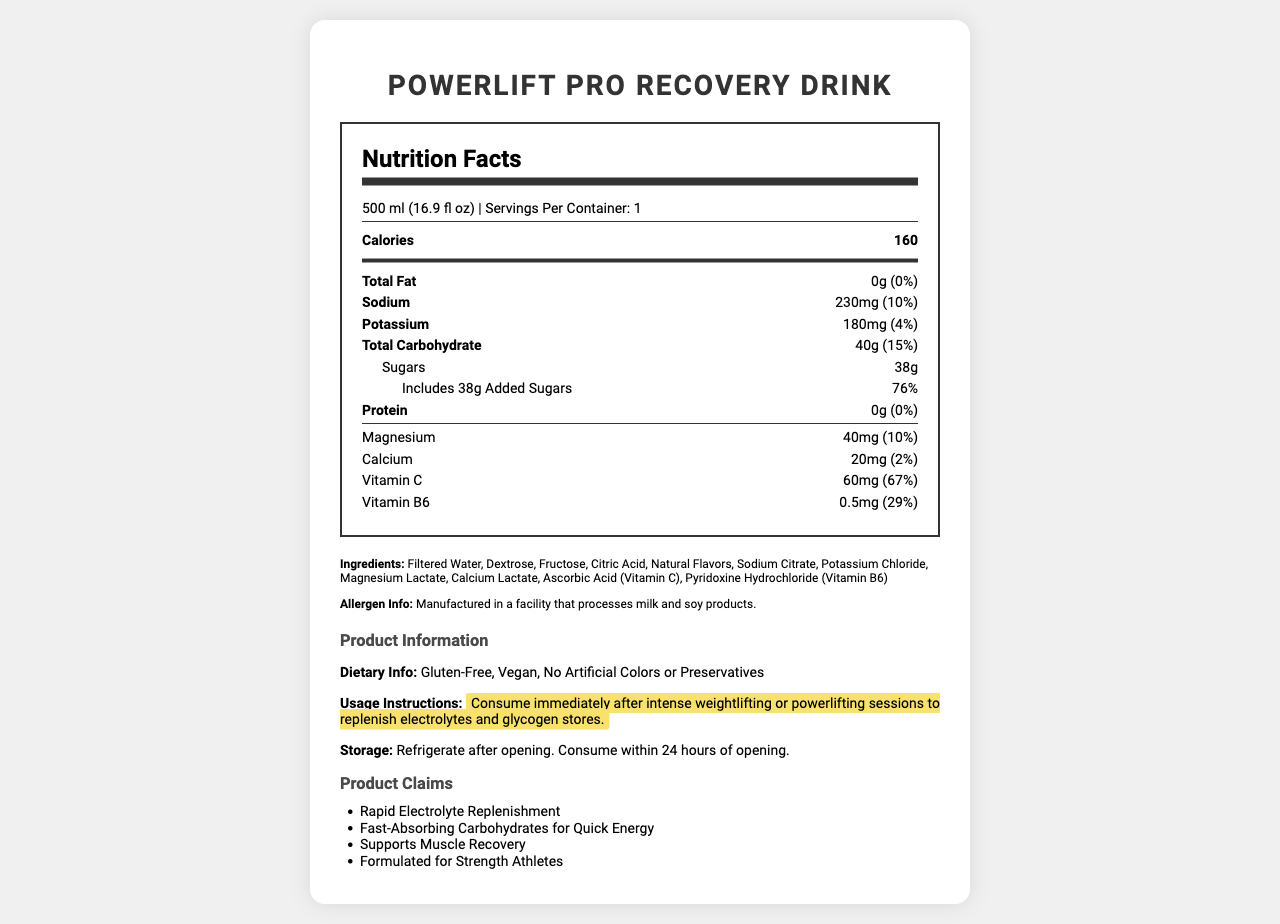what is the serving size of PowerLift Pro Recovery Drink? The serving size is mentioned at the beginning of the nutrition label under the "Nutrition Facts" heading.
Answer: 500 ml (16.9 fl oz) How many calories are there in one serving? The number of calories is listed in a bold font in the nutrition label.
Answer: 160 What is the total carbohydrate content per serving? The total carbohydrate content is displayed under the nutrition information, along with the daily value percentage.
Answer: 40g (15%) How much sodium does this drink contain per serving? The amount of sodium is given as 230mg, which constitutes 10% of the daily value.
Answer: 230mg (10%) What minerals are present in the PowerLift Pro Recovery Drink? These minerals are listed along with their respective amounts and daily values in the nutrition label.
Answer: Sodium, Potassium, Magnesium, Calcium Does this drink contain any added sugars? Under the sugars section, it mentions "Includes 38g Added Sugars" with a daily value percentage of 76%.
Answer: Yes Which vitamin has the highest daily value percentage in this drink? A. Vitamin A B. Vitamin C C. Vitamin D D. Vitamin B6 Vitamin C (60mg) has the highest daily value percentage of 67% compared to other vitamins listed.
Answer: B What kind of dietary claims are made about PowerLift Pro Recovery Drink? A. Gluten-Free, Vegan B. Contains Artificial Colors, Contains Preservatives C. Low Sodium, Low Sugar The drink is claimed to be Gluten-Free and Vegan according to the product information section.
Answer: A Are there any allergens associated with the PowerLift Pro Recovery Drink? The allergen information states that it is manufactured in a facility that processes milk and soy products.
Answer: Yes Is this product recommended to be consumed after weightlifting sessions? The usage instructions highlight that it should be consumed immediately after intense weightlifting or powerlifting sessions.
Answer: Yes Summarize the main idea of the PowerLift Pro Recovery Drink nutrition facts label. The document provides detailed nutritional information, ingredients, allergen info, dietary claims, usage instructions, and product claims designed to highlight the drink's benefits for recovery and electrolyte replenishment.
Answer: The PowerLift Pro Recovery Drink is a post-workout beverage designed to replenish electrolytes and glycogen stores. It contains key nutrients such as sodium, potassium, magnesium, and vitamins C and B6. The drink is gluten-free, vegan, and contains no artificial colors or preservatives, but it includes 38g of added sugars. It provides 160 calories per 500 ml serving and is recommended for consumption after intense weightlifting sessions. How many grams of protein are in each serving of this drink? The protein content is listed as "0g" with a daily value percentage of "0%".
Answer: 0g What is the main source of carbohydrates in the PowerLift Pro Recovery Drink? The ingredients list specifically mentions dextrose and fructose, which are types of sugars and fast-absorbing carbohydrates.
Answer: Dextrose, Fructose How should this drink be stored after opening? The storage instructions specify that the drink should be refrigerated after opening and consumed within 24 hours.
Answer: Refrigerate after opening. Consume within 24 hours of opening. How many servings are there per container of the PowerLift Pro Recovery Drink? The label states that there is one serving per container.
Answer: 1 What is the total fat content in each serving? The total fat content is indicated as "0g" with a daily value percentage of "0%".
Answer: 0g (0%) Can you determine if this drink is low in sugar? The drink contains 38g of sugars, which includes added sugars, making it high in sugar; thus, it cannot be considered low in sugar.
Answer: No 